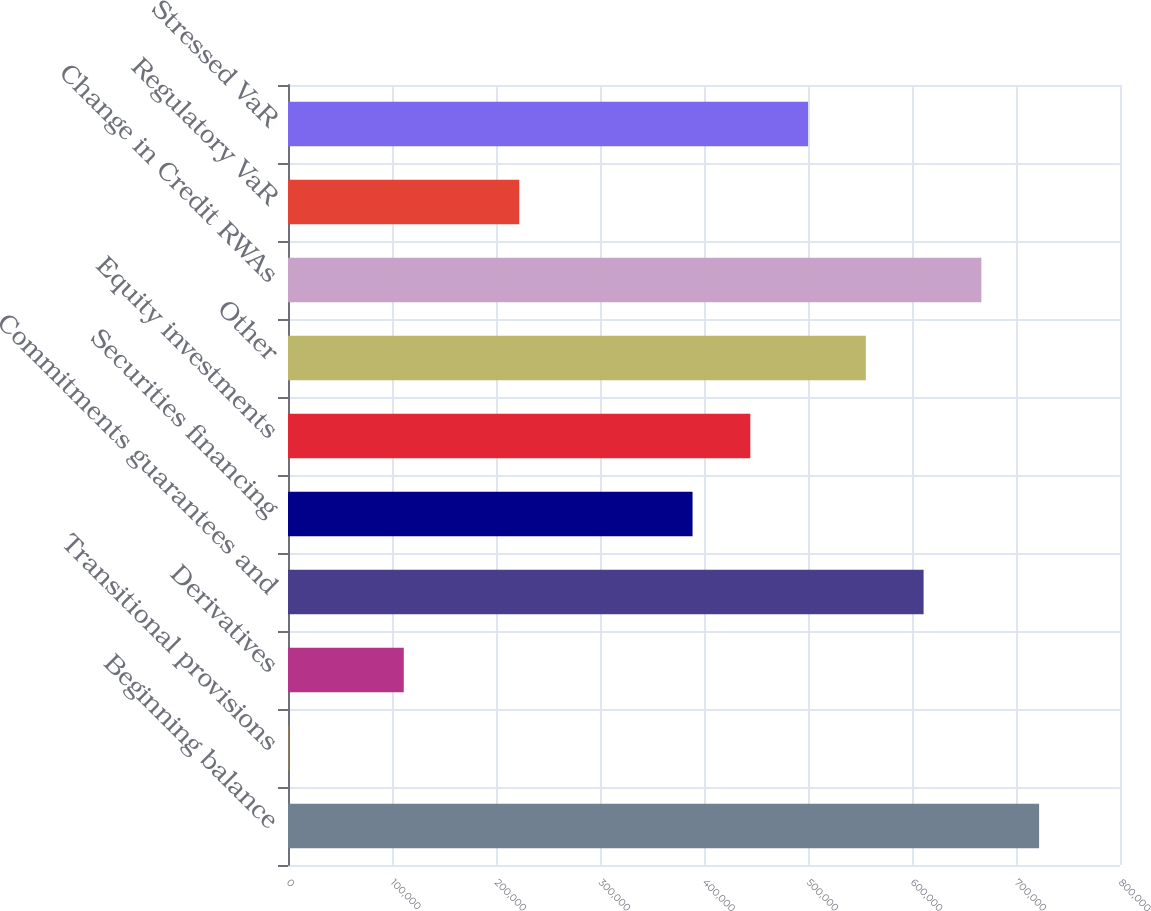Convert chart to OTSL. <chart><loc_0><loc_0><loc_500><loc_500><bar_chart><fcel>Beginning balance<fcel>Transitional provisions<fcel>Derivatives<fcel>Commitments guarantees and<fcel>Securities financing<fcel>Equity investments<fcel>Other<fcel>Change in Credit RWAs<fcel>Regulatory VaR<fcel>Stressed VaR<nl><fcel>722224<fcel>233<fcel>111309<fcel>611149<fcel>388998<fcel>444535<fcel>555611<fcel>666687<fcel>222384<fcel>500073<nl></chart> 